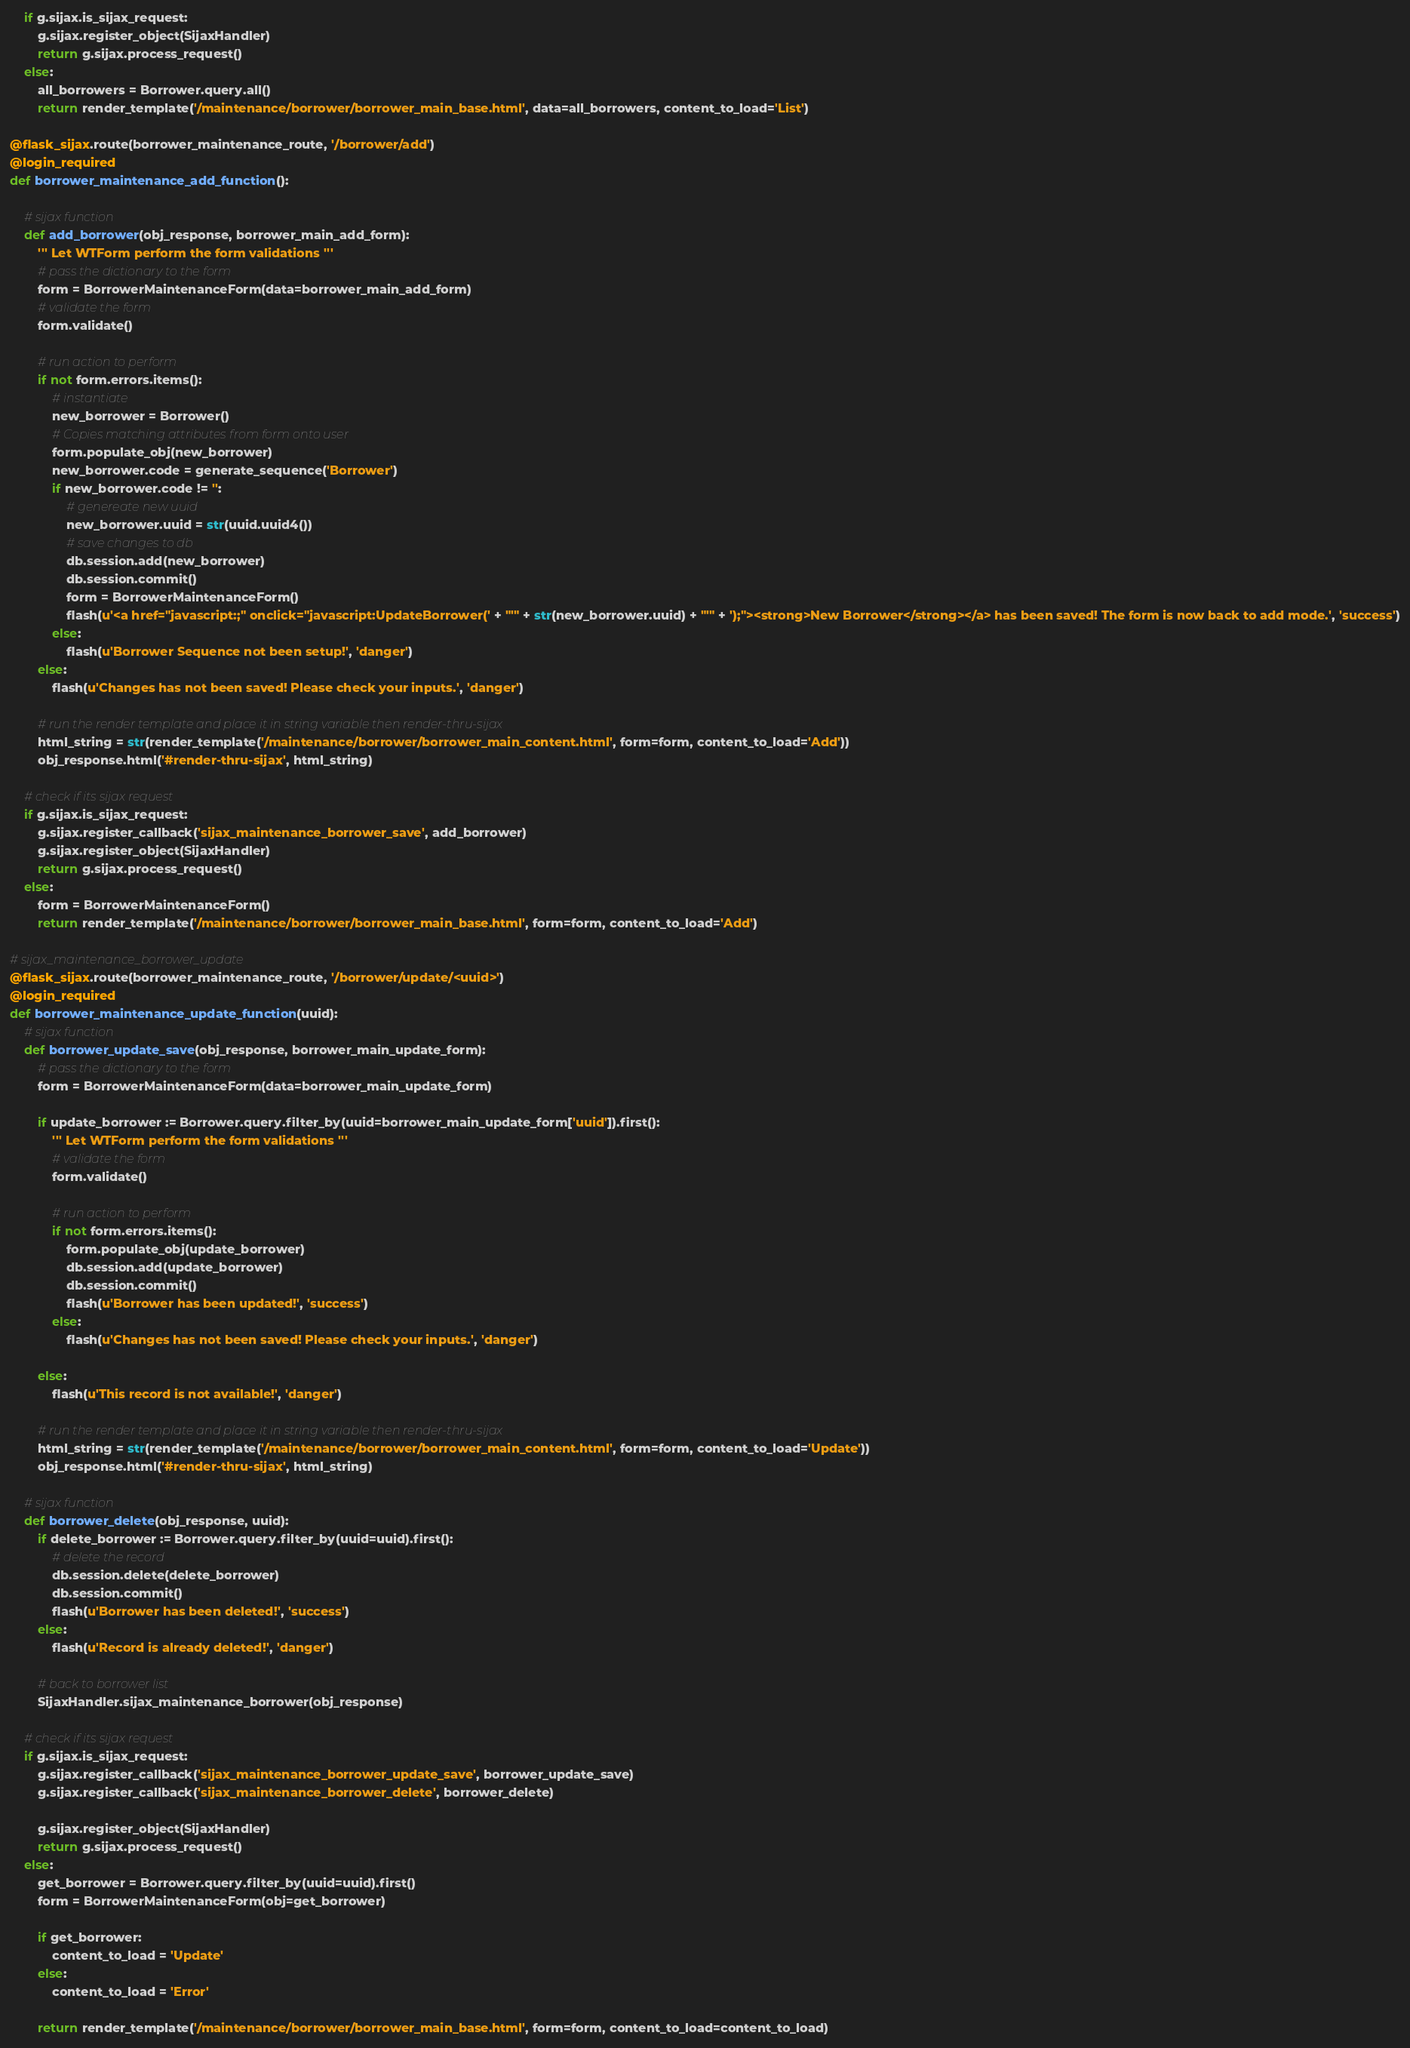<code> <loc_0><loc_0><loc_500><loc_500><_Python_>    if g.sijax.is_sijax_request:
        g.sijax.register_object(SijaxHandler)
        return g.sijax.process_request()
    else:
        all_borrowers = Borrower.query.all()
        return render_template('/maintenance/borrower/borrower_main_base.html', data=all_borrowers, content_to_load='List')

@flask_sijax.route(borrower_maintenance_route, '/borrower/add')
@login_required
def borrower_maintenance_add_function():

    # sijax function
    def add_borrower(obj_response, borrower_main_add_form):
        ''' Let WTForm perform the form validations '''
        # pass the dictionary to the form
        form = BorrowerMaintenanceForm(data=borrower_main_add_form)
        # validate the form
        form.validate()

        # run action to perform
        if not form.errors.items():
            # instantiate 
            new_borrower = Borrower()
            # Copies matching attributes from form onto user
            form.populate_obj(new_borrower) 
            new_borrower.code = generate_sequence('Borrower')
            if new_borrower.code != '':
                # genereate new uuid 
                new_borrower.uuid = str(uuid.uuid4())
                # save changes to db
                db.session.add(new_borrower)
                db.session.commit()
                form = BorrowerMaintenanceForm()
                flash(u'<a href="javascript:;" onclick="javascript:UpdateBorrower(' + "'" + str(new_borrower.uuid) + "'" + ');"><strong>New Borrower</strong></a> has been saved! The form is now back to add mode.', 'success')
            else:
                flash(u'Borrower Sequence not been setup!', 'danger')
        else:
            flash(u'Changes has not been saved! Please check your inputs.', 'danger')

        # run the render template and place it in string variable then render-thru-sijax
        html_string = str(render_template('/maintenance/borrower/borrower_main_content.html', form=form, content_to_load='Add'))
        obj_response.html('#render-thru-sijax', html_string)

    # check if its sijax request
    if g.sijax.is_sijax_request:
        g.sijax.register_callback('sijax_maintenance_borrower_save', add_borrower)
        g.sijax.register_object(SijaxHandler)
        return g.sijax.process_request()
    else:
        form = BorrowerMaintenanceForm()
        return render_template('/maintenance/borrower/borrower_main_base.html', form=form, content_to_load='Add')

# sijax_maintenance_borrower_update
@flask_sijax.route(borrower_maintenance_route, '/borrower/update/<uuid>')
@login_required
def borrower_maintenance_update_function(uuid):
    # sijax function
    def borrower_update_save(obj_response, borrower_main_update_form):
        # pass the dictionary to the form
        form = BorrowerMaintenanceForm(data=borrower_main_update_form)

        if update_borrower := Borrower.query.filter_by(uuid=borrower_main_update_form['uuid']).first():
            ''' Let WTForm perform the form validations '''
            # validate the form
            form.validate()

            # run action to perform
            if not form.errors.items():
                form.populate_obj(update_borrower)
                db.session.add(update_borrower)
                db.session.commit()
                flash(u'Borrower has been updated!', 'success')
            else:
                flash(u'Changes has not been saved! Please check your inputs.', 'danger')

        else:
            flash(u'This record is not available!', 'danger')

        # run the render template and place it in string variable then render-thru-sijax
        html_string = str(render_template('/maintenance/borrower/borrower_main_content.html', form=form, content_to_load='Update'))
        obj_response.html('#render-thru-sijax', html_string)

    # sijax function
    def borrower_delete(obj_response, uuid):
        if delete_borrower := Borrower.query.filter_by(uuid=uuid).first():
            # delete the record
            db.session.delete(delete_borrower)
            db.session.commit()    
            flash(u'Borrower has been deleted!', 'success')        
        else:
            flash(u'Record is already deleted!', 'danger')

        # back to borrower list
        SijaxHandler.sijax_maintenance_borrower(obj_response)    

    # check if its sijax request
    if g.sijax.is_sijax_request:
        g.sijax.register_callback('sijax_maintenance_borrower_update_save', borrower_update_save)
        g.sijax.register_callback('sijax_maintenance_borrower_delete', borrower_delete)
        
        g.sijax.register_object(SijaxHandler)
        return g.sijax.process_request()
    else:
        get_borrower = Borrower.query.filter_by(uuid=uuid).first()
        form = BorrowerMaintenanceForm(obj=get_borrower)

        if get_borrower:
            content_to_load = 'Update'
        else:
            content_to_load = 'Error'

        return render_template('/maintenance/borrower/borrower_main_base.html', form=form, content_to_load=content_to_load)
</code> 